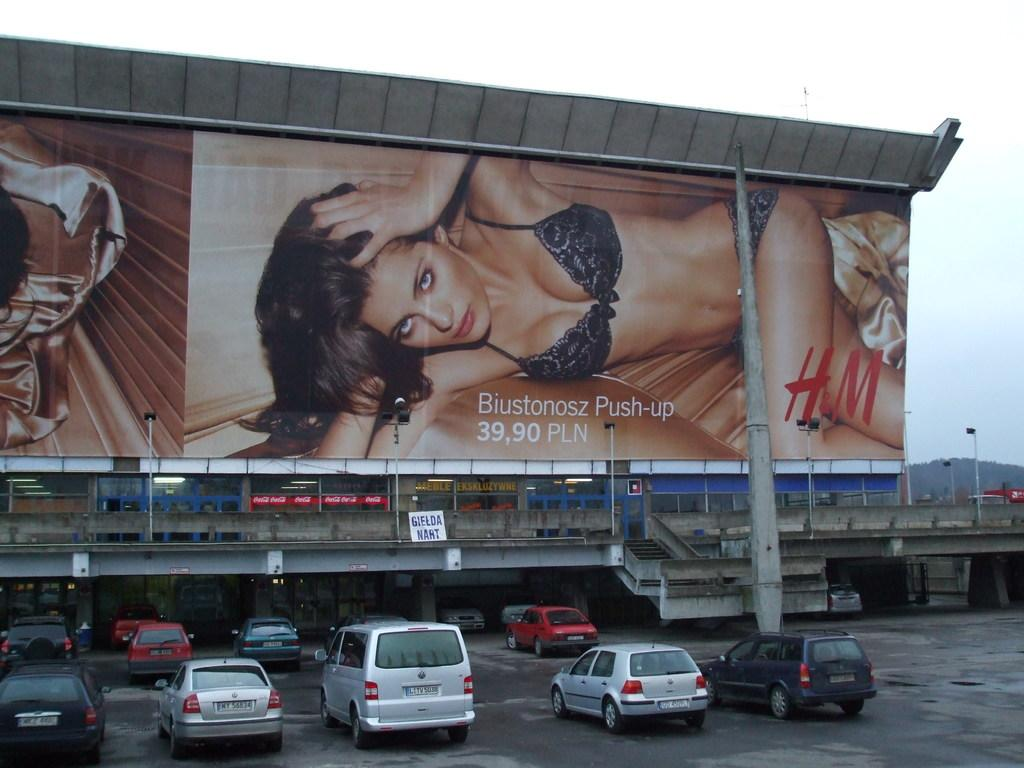<image>
Offer a succinct explanation of the picture presented. Billboard with a woman advertising push-up bras with cars parked next to it. 